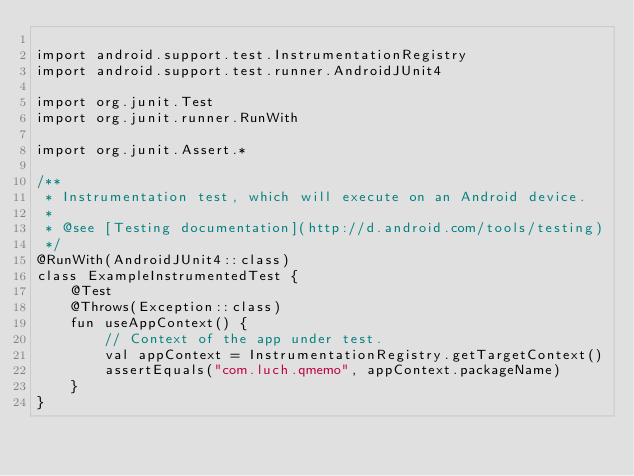Convert code to text. <code><loc_0><loc_0><loc_500><loc_500><_Kotlin_>
import android.support.test.InstrumentationRegistry
import android.support.test.runner.AndroidJUnit4

import org.junit.Test
import org.junit.runner.RunWith

import org.junit.Assert.*

/**
 * Instrumentation test, which will execute on an Android device.
 *
 * @see [Testing documentation](http://d.android.com/tools/testing)
 */
@RunWith(AndroidJUnit4::class)
class ExampleInstrumentedTest {
    @Test
    @Throws(Exception::class)
    fun useAppContext() {
        // Context of the app under test.
        val appContext = InstrumentationRegistry.getTargetContext()
        assertEquals("com.luch.qmemo", appContext.packageName)
    }
}
</code> 